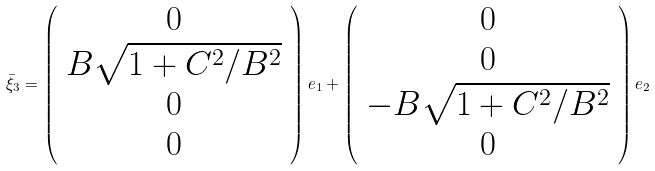<formula> <loc_0><loc_0><loc_500><loc_500>\bar { \xi } _ { 3 } = \left ( \begin{array} { c } 0 \\ B \sqrt { 1 + C ^ { 2 } / B ^ { 2 } } \\ 0 \\ 0 \end{array} \right ) e _ { 1 } + \left ( \begin{array} { c } 0 \\ 0 \\ - B \sqrt { 1 + C ^ { 2 } / B ^ { 2 } } \\ 0 \end{array} \right ) e _ { 2 }</formula> 